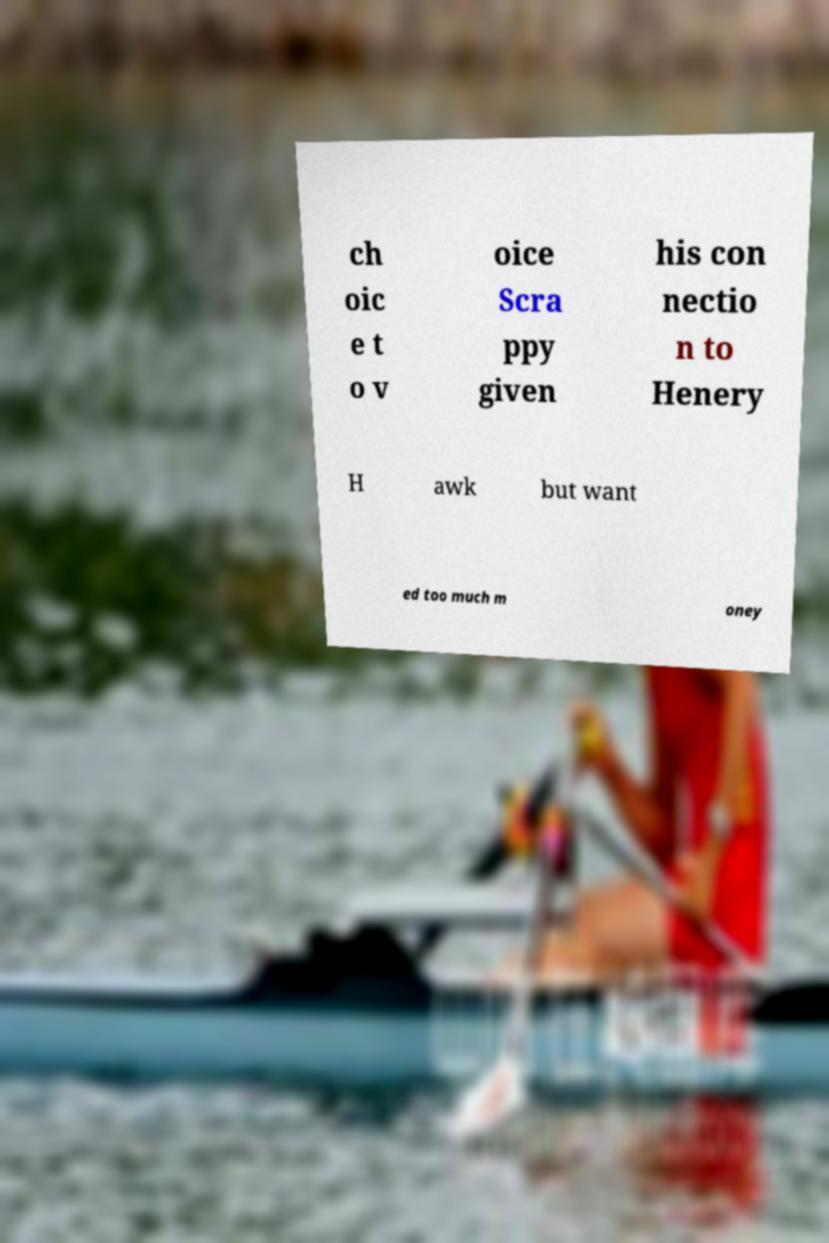Can you read and provide the text displayed in the image?This photo seems to have some interesting text. Can you extract and type it out for me? ch oic e t o v oice Scra ppy given his con nectio n to Henery H awk but want ed too much m oney 